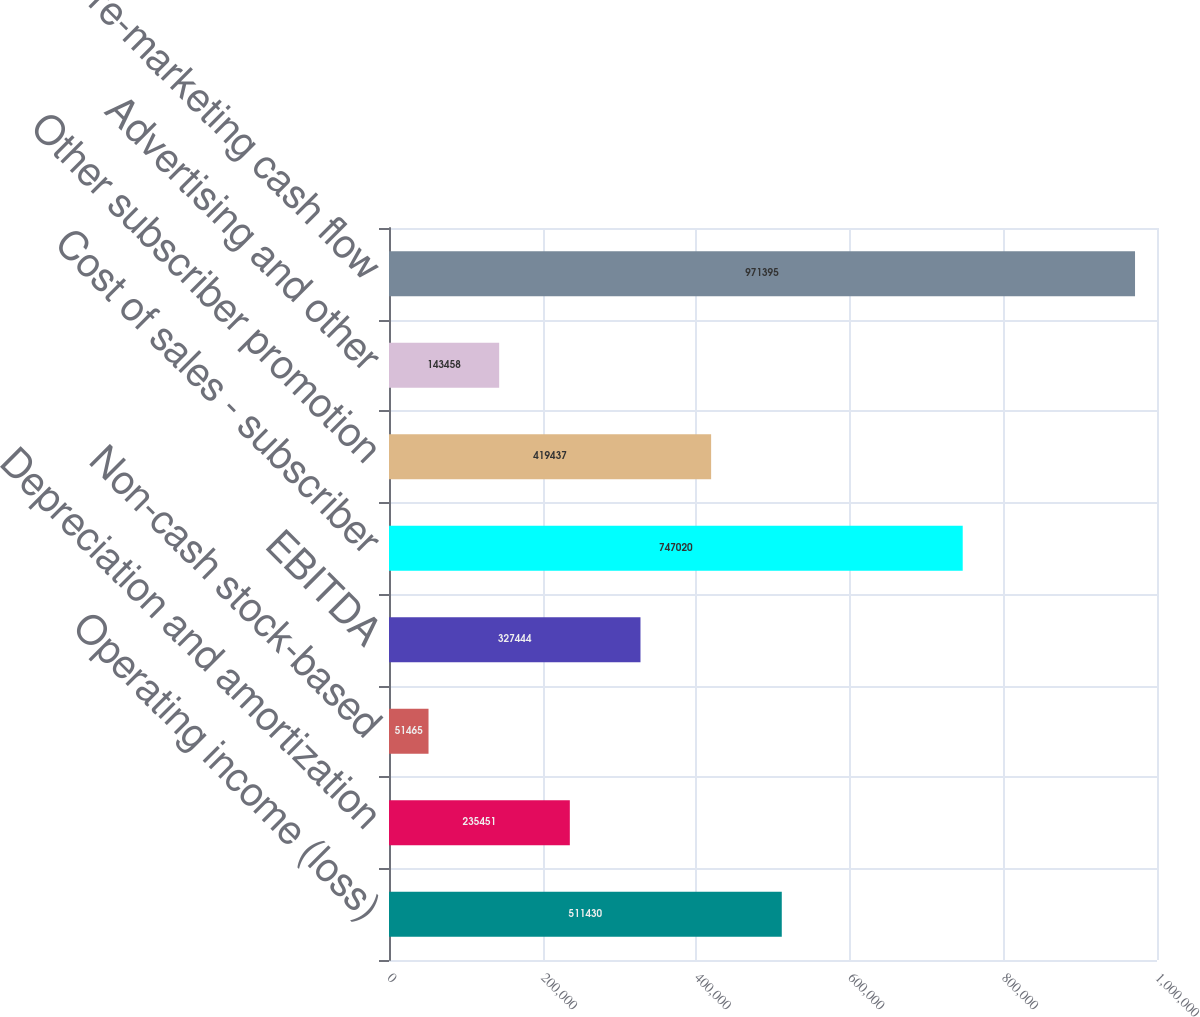Convert chart. <chart><loc_0><loc_0><loc_500><loc_500><bar_chart><fcel>Operating income (loss)<fcel>Depreciation and amortization<fcel>Non-cash stock-based<fcel>EBITDA<fcel>Cost of sales - subscriber<fcel>Other subscriber promotion<fcel>Advertising and other<fcel>Pre-marketing cash flow<nl><fcel>511430<fcel>235451<fcel>51465<fcel>327444<fcel>747020<fcel>419437<fcel>143458<fcel>971395<nl></chart> 